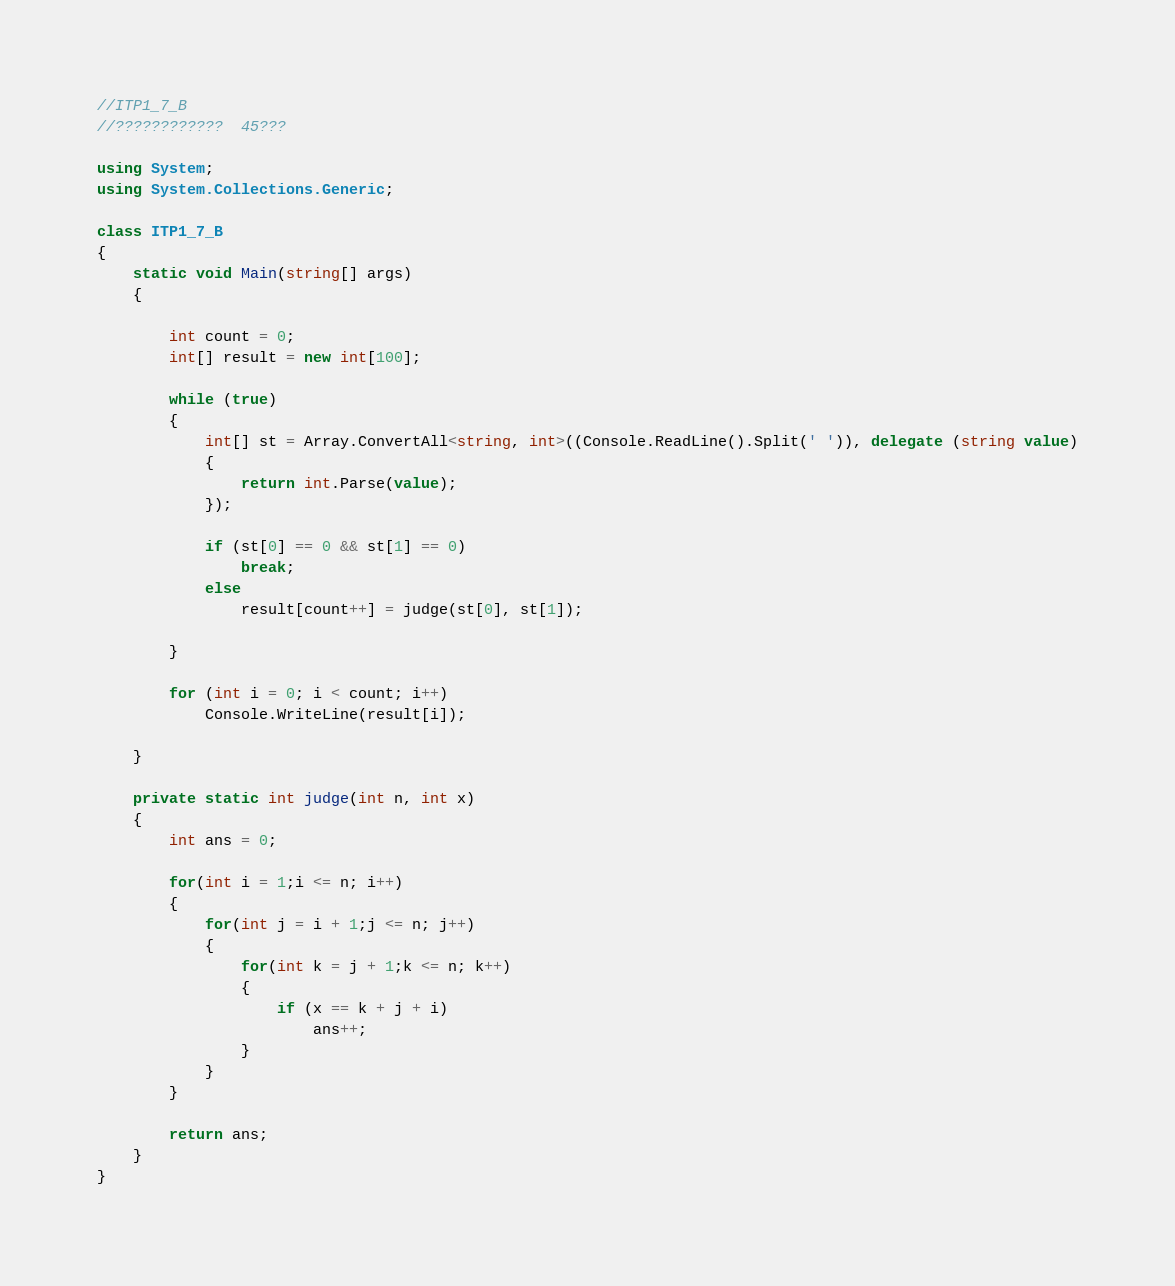Convert code to text. <code><loc_0><loc_0><loc_500><loc_500><_C#_>//ITP1_7_B
//????????????  45???

using System;
using System.Collections.Generic;

class ITP1_7_B
{
    static void Main(string[] args)
    {

        int count = 0;
        int[] result = new int[100];

        while (true)
        {
            int[] st = Array.ConvertAll<string, int>((Console.ReadLine().Split(' ')), delegate (string value)
            {
                return int.Parse(value);
            });

            if (st[0] == 0 && st[1] == 0)
                break;
            else
                result[count++] = judge(st[0], st[1]);

        }

        for (int i = 0; i < count; i++)
            Console.WriteLine(result[i]);

    }

    private static int judge(int n, int x)
    {
        int ans = 0;

        for(int i = 1;i <= n; i++)
        {
            for(int j = i + 1;j <= n; j++)
            {
                for(int k = j + 1;k <= n; k++)
                {
                    if (x == k + j + i)
                        ans++;
                }
            }    
        }

        return ans;
    }
}</code> 